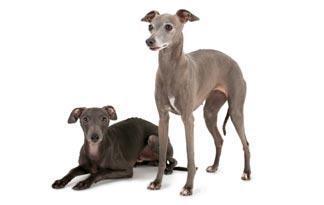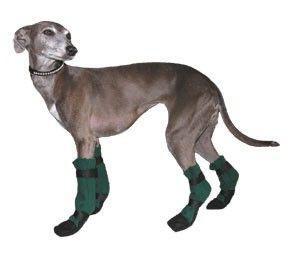The first image is the image on the left, the second image is the image on the right. Assess this claim about the two images: "At least one of the dogs is wearing something on its feet.". Correct or not? Answer yes or no. Yes. 